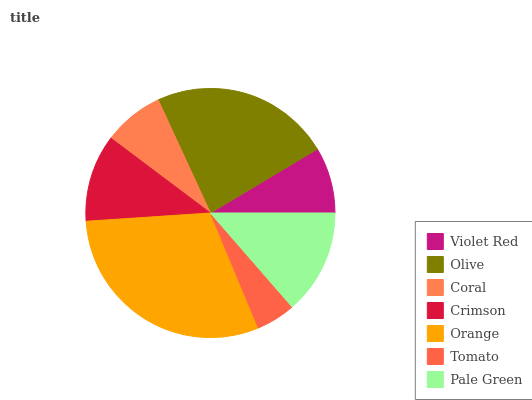Is Tomato the minimum?
Answer yes or no. Yes. Is Orange the maximum?
Answer yes or no. Yes. Is Olive the minimum?
Answer yes or no. No. Is Olive the maximum?
Answer yes or no. No. Is Olive greater than Violet Red?
Answer yes or no. Yes. Is Violet Red less than Olive?
Answer yes or no. Yes. Is Violet Red greater than Olive?
Answer yes or no. No. Is Olive less than Violet Red?
Answer yes or no. No. Is Crimson the high median?
Answer yes or no. Yes. Is Crimson the low median?
Answer yes or no. Yes. Is Violet Red the high median?
Answer yes or no. No. Is Violet Red the low median?
Answer yes or no. No. 